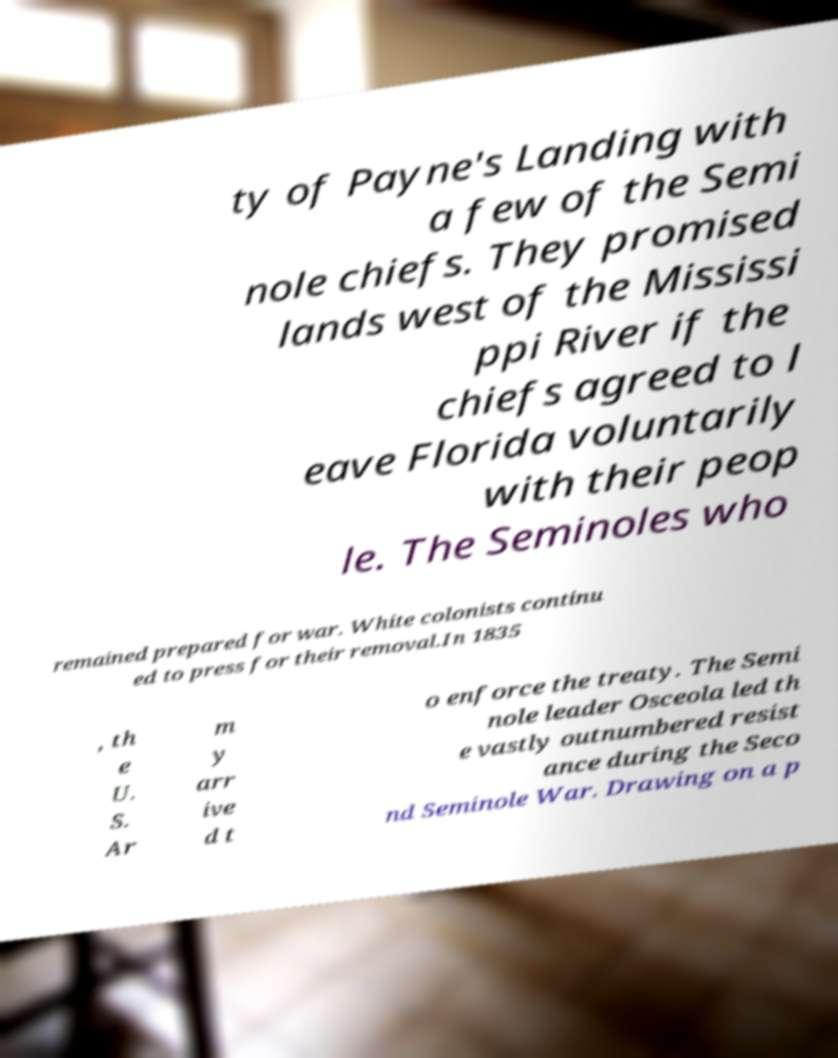There's text embedded in this image that I need extracted. Can you transcribe it verbatim? ty of Payne's Landing with a few of the Semi nole chiefs. They promised lands west of the Mississi ppi River if the chiefs agreed to l eave Florida voluntarily with their peop le. The Seminoles who remained prepared for war. White colonists continu ed to press for their removal.In 1835 , th e U. S. Ar m y arr ive d t o enforce the treaty. The Semi nole leader Osceola led th e vastly outnumbered resist ance during the Seco nd Seminole War. Drawing on a p 